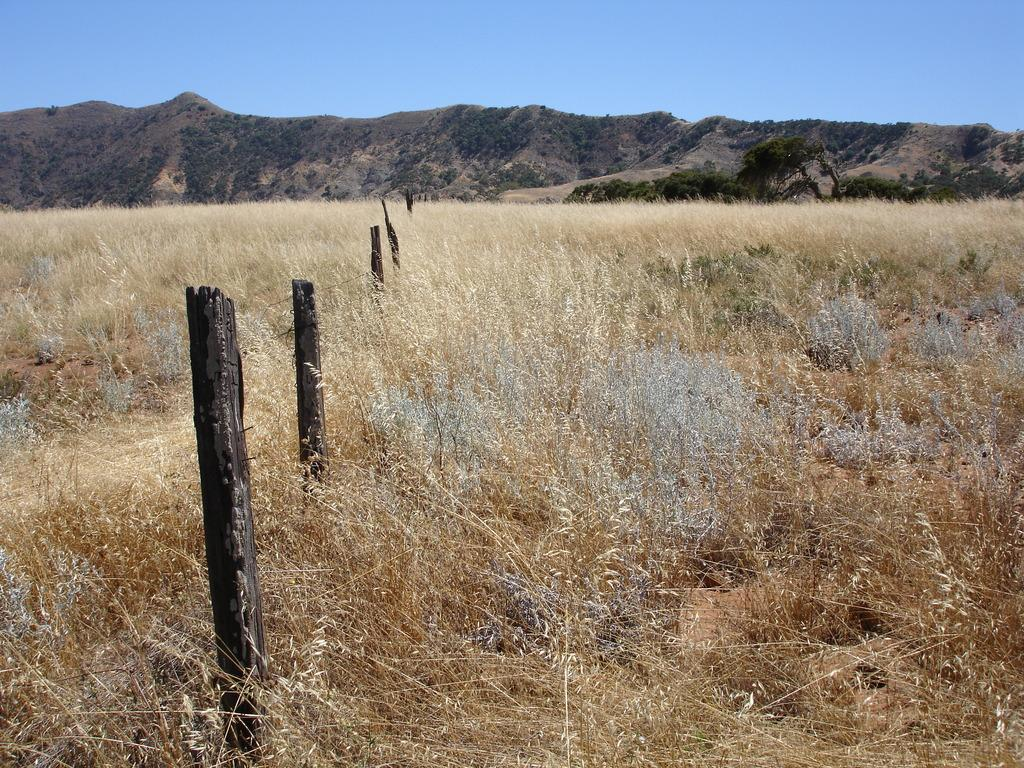What type of vegetation is in the center of the image? There is dry grass in the center of the image. What natural feature can be seen in the background of the image? There are mountains in the background of the image. What type of fencing is present in the image? There is a wooden fencing in the image. What is visible at the top of the image? The sky is visible at the top of the image. Where can the quartz be found in the image? There is no quartz present in the image. What type of toys are scattered around the dry grass in the image? There are no toys present in the image; it features dry grass, mountains, wooden fencing, and the sky. 